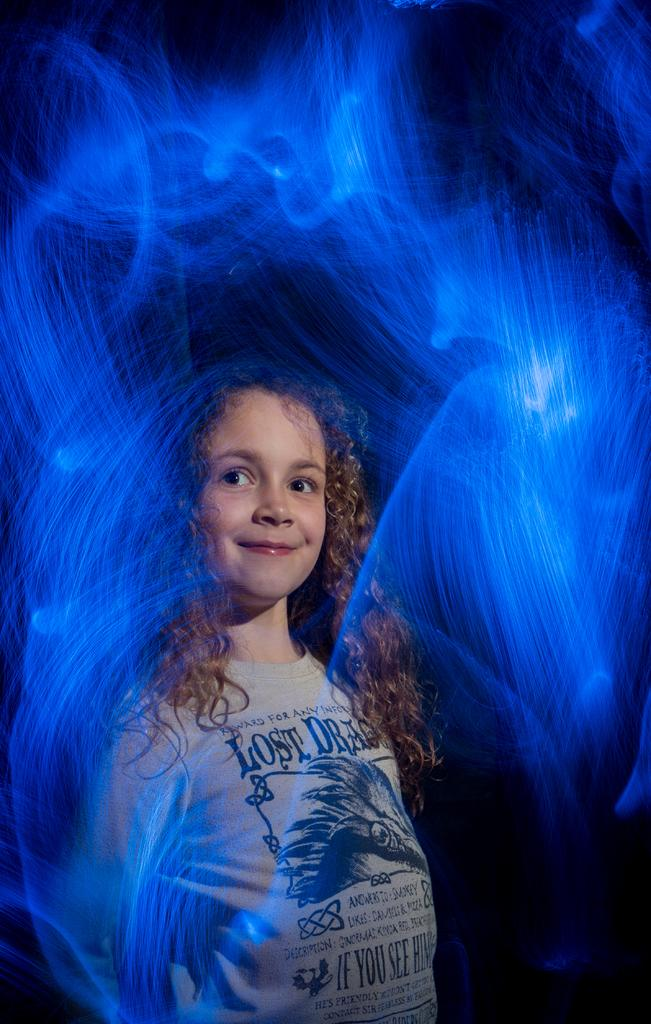Who is the main subject in the image? There is a girl in the image. What is the girl's expression in the image? The girl is smiling. What can be seen on the girl's t-shirt? There is text on the girl's t-shirt. What type of lighting is present in the image? There is blue color light visible in the image. How many sisters does the girl have in the image? There is no information about sisters in the image. Is there an umbrella visible in the image? There is no umbrella present in the image. 